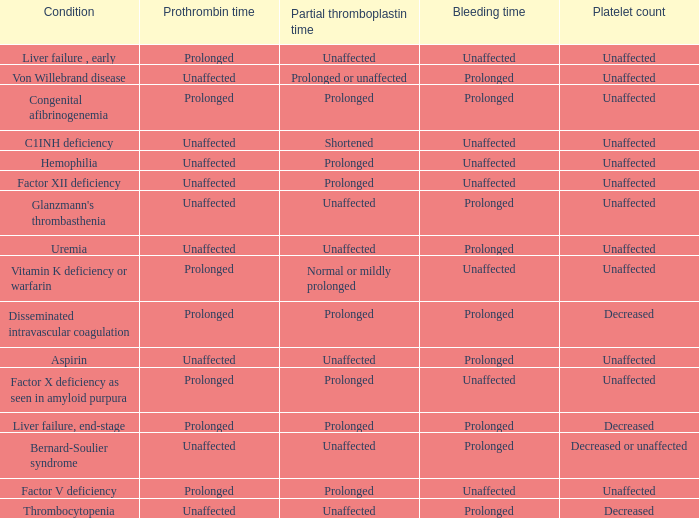Which Prothrombin time has a Platelet count of unaffected, and a Bleeding time of unaffected, and a Partial thromboplastin time of normal or mildly prolonged? Prolonged. 